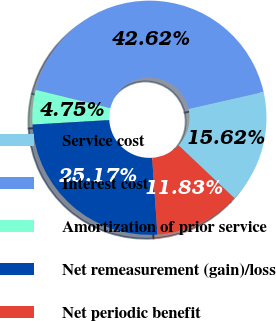<chart> <loc_0><loc_0><loc_500><loc_500><pie_chart><fcel>Service cost<fcel>Interest cost<fcel>Amortization of prior service<fcel>Net remeasurement (gain)/loss<fcel>Net periodic benefit<nl><fcel>15.62%<fcel>42.62%<fcel>4.75%<fcel>25.17%<fcel>11.83%<nl></chart> 